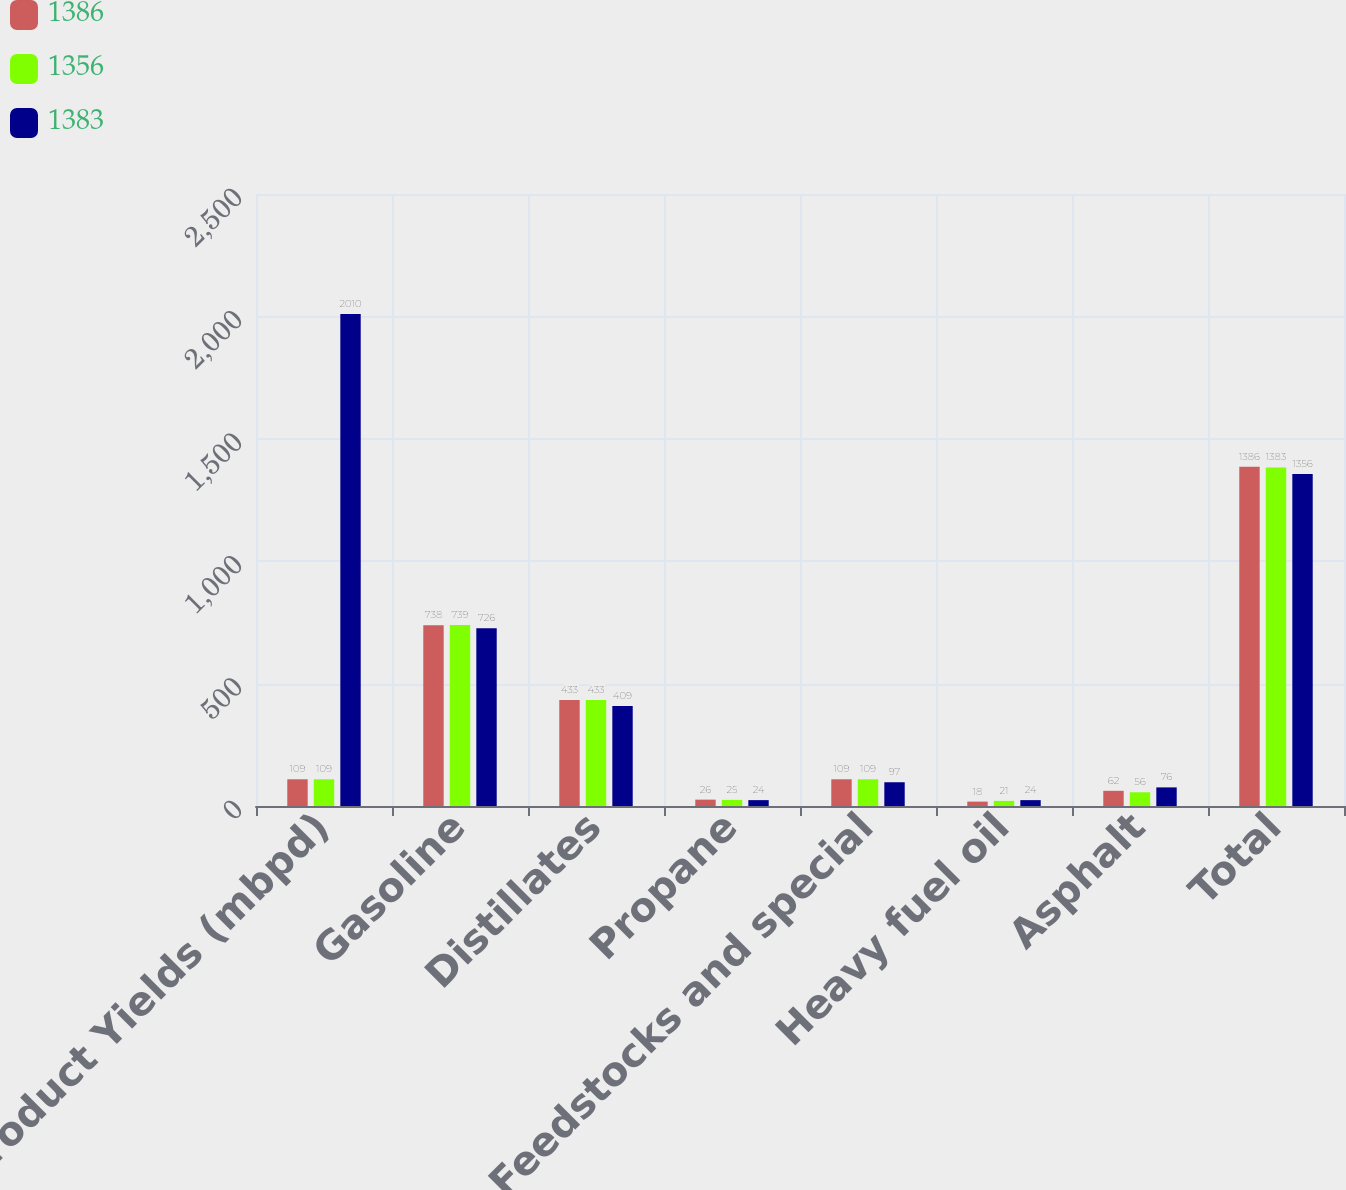<chart> <loc_0><loc_0><loc_500><loc_500><stacked_bar_chart><ecel><fcel>Refined Product Yields (mbpd)<fcel>Gasoline<fcel>Distillates<fcel>Propane<fcel>Feedstocks and special<fcel>Heavy fuel oil<fcel>Asphalt<fcel>Total<nl><fcel>1386<fcel>109<fcel>738<fcel>433<fcel>26<fcel>109<fcel>18<fcel>62<fcel>1386<nl><fcel>1356<fcel>109<fcel>739<fcel>433<fcel>25<fcel>109<fcel>21<fcel>56<fcel>1383<nl><fcel>1383<fcel>2010<fcel>726<fcel>409<fcel>24<fcel>97<fcel>24<fcel>76<fcel>1356<nl></chart> 